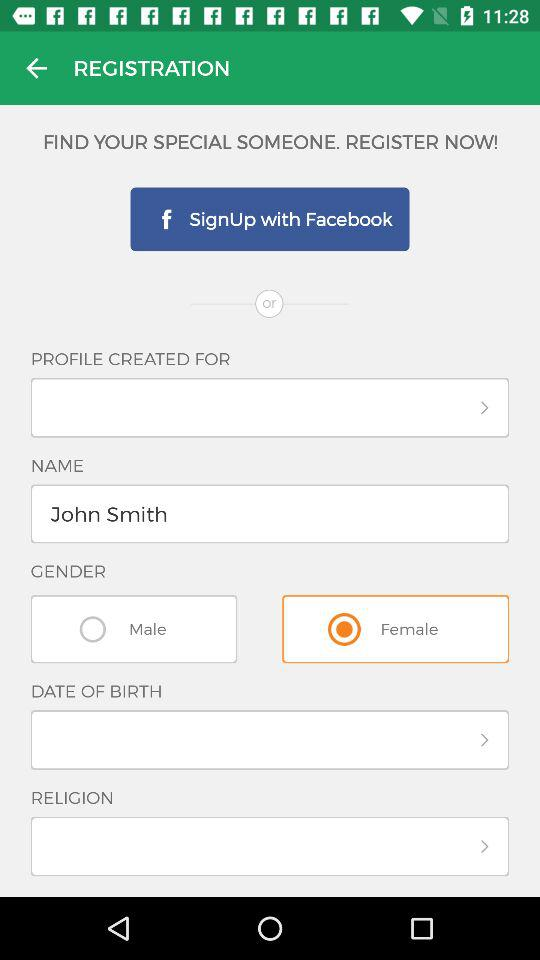What is the selected gender? The selected gender is female. 